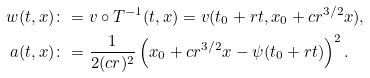<formula> <loc_0><loc_0><loc_500><loc_500>w ( t , x ) & \colon = v \circ T ^ { - 1 } ( t , x ) = v ( t _ { 0 } + r t , x _ { 0 } + c r ^ { 3 / 2 } x ) , \\ a ( t , x ) & \colon = \frac { 1 } { 2 ( c r ) ^ { 2 } } \left ( x _ { 0 } + c r ^ { 3 / 2 } x - \psi ( t _ { 0 } + r t ) \right ) ^ { 2 } .</formula> 